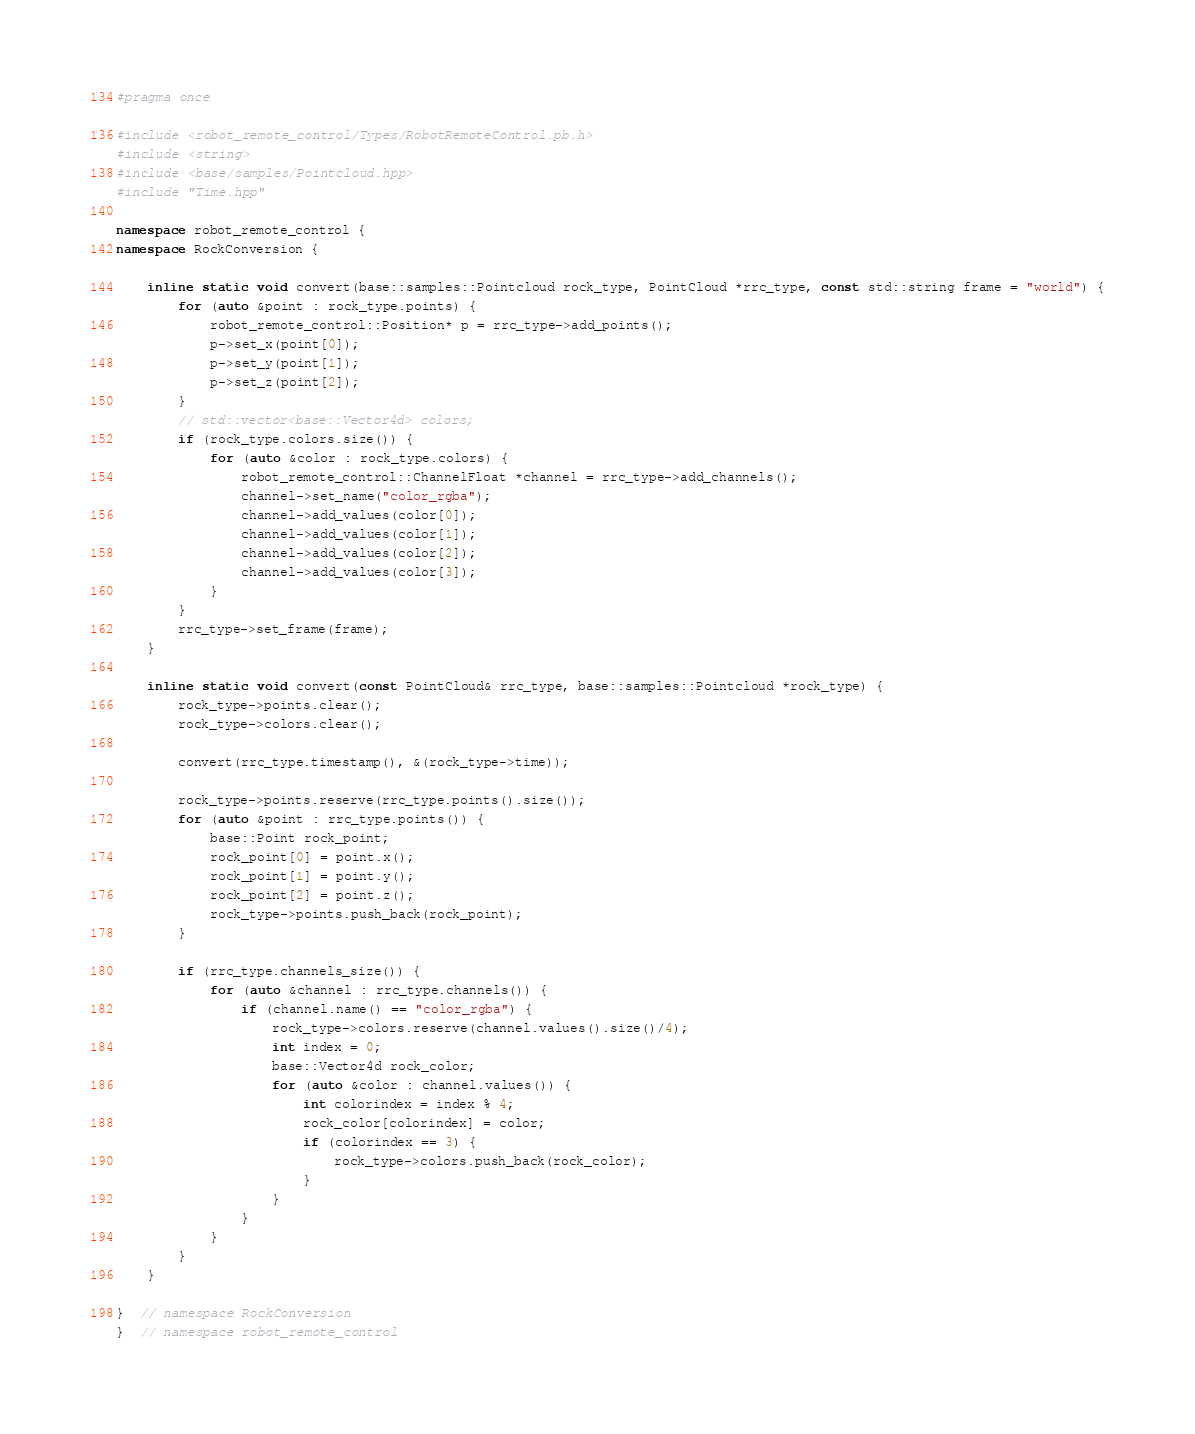Convert code to text. <code><loc_0><loc_0><loc_500><loc_500><_C++_>#pragma once

#include <robot_remote_control/Types/RobotRemoteControl.pb.h>
#include <string>
#include <base/samples/Pointcloud.hpp>
#include "Time.hpp"

namespace robot_remote_control {
namespace RockConversion {

    inline static void convert(base::samples::Pointcloud rock_type, PointCloud *rrc_type, const std::string frame = "world") {
        for (auto &point : rock_type.points) {
            robot_remote_control::Position* p = rrc_type->add_points();
            p->set_x(point[0]);
            p->set_y(point[1]);
            p->set_z(point[2]);
        }
        // std::vector<base::Vector4d> colors;
        if (rock_type.colors.size()) {
            for (auto &color : rock_type.colors) {
                robot_remote_control::ChannelFloat *channel = rrc_type->add_channels();
                channel->set_name("color_rgba");
                channel->add_values(color[0]);
                channel->add_values(color[1]);
                channel->add_values(color[2]);
                channel->add_values(color[3]);
            }
        }
        rrc_type->set_frame(frame);
    }

    inline static void convert(const PointCloud& rrc_type, base::samples::Pointcloud *rock_type) {
        rock_type->points.clear();
        rock_type->colors.clear();

        convert(rrc_type.timestamp(), &(rock_type->time));

        rock_type->points.reserve(rrc_type.points().size());
        for (auto &point : rrc_type.points()) {
            base::Point rock_point;
            rock_point[0] = point.x();
            rock_point[1] = point.y();
            rock_point[2] = point.z();
            rock_type->points.push_back(rock_point);
        }

        if (rrc_type.channels_size()) {
            for (auto &channel : rrc_type.channels()) {
                if (channel.name() == "color_rgba") {
                    rock_type->colors.reserve(channel.values().size()/4);
                    int index = 0;
                    base::Vector4d rock_color;
                    for (auto &color : channel.values()) {
                        int colorindex = index % 4;
                        rock_color[colorindex] = color;
                        if (colorindex == 3) {
                            rock_type->colors.push_back(rock_color);
                        }
                    }
                }
            }
        }
    }

}  // namespace RockConversion
}  // namespace robot_remote_control
</code> 